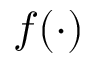<formula> <loc_0><loc_0><loc_500><loc_500>f ( \cdot )</formula> 